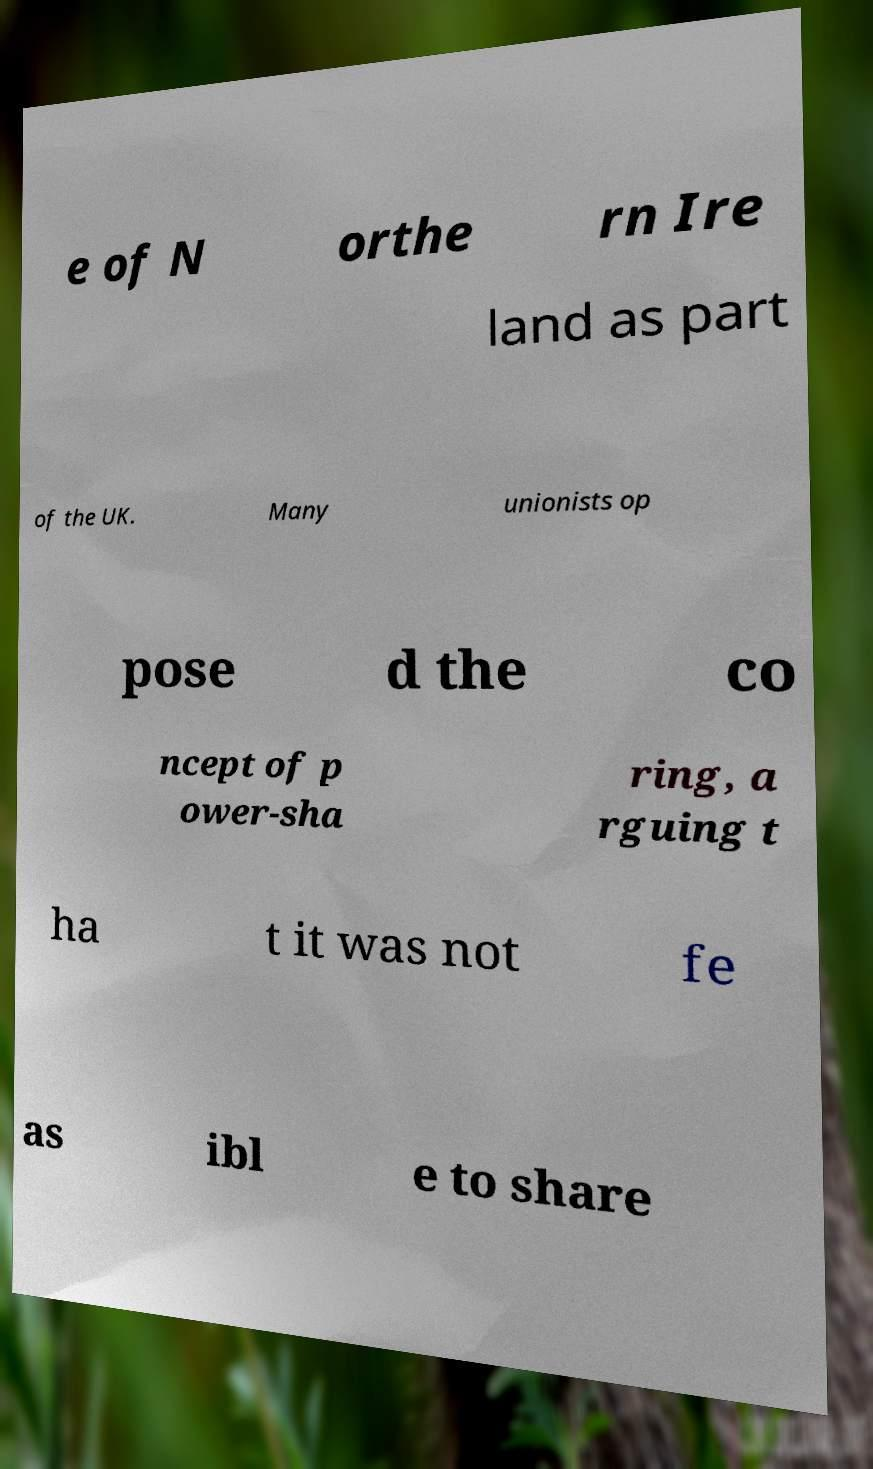Please read and relay the text visible in this image. What does it say? e of N orthe rn Ire land as part of the UK. Many unionists op pose d the co ncept of p ower-sha ring, a rguing t ha t it was not fe as ibl e to share 